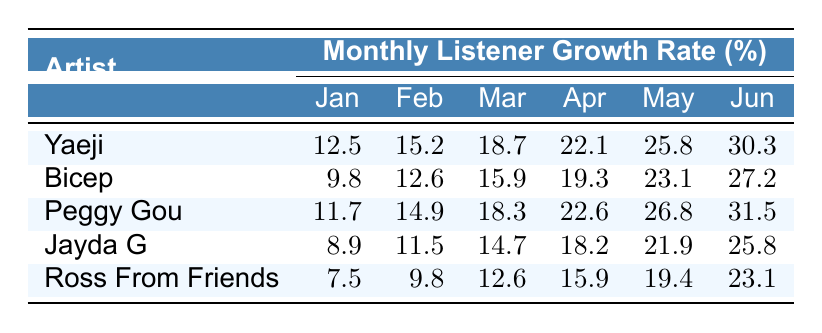What was Yaeji's listener growth rate in April in New York? The table shows that Yaeji's listener growth rate in New York for April is listed under the April column, which is 22.1%
Answer: 22.1% Which artist had the highest growth rate in London in June? By examining the June column for London, I can see that Peggy Gou's growth rate is 33.8%, which is higher than the others in that city
Answer: Peggy Gou What is the average listener growth rate for Ross From Friends across all months in Tokyo? To find the average, add up Ross From Friends' percentages in Tokyo: (6.1 + 8.2 + 10.7 + 13.6 + 16.8 + 20.3) = 75.7, then divide by 6, giving 75.7 / 6 = 12.62
Answer: 12.62 Was there any artist in Berlin whose growth rate was above 30% in May? Checking the May column for Berlin shows that the highest rate is 29.7% for Bicep, which means no artist reached 30%
Answer: No Which city had the highest monthly growth rate for Peggy Gou in March? For March, Peggy Gou's growth rate across the cities is compared: New York (18.3%), Los Angeles (17.1%), London (19.6%), Berlin (21.4%), and Tokyo (16.3%). The highest value is 21.4% in Berlin
Answer: Berlin How much higher is the growth rate of Yaeji in June compared to Jayda G in the same month? Yaeji's growth rate in June is 30.3%, while Jayda G's is 25.8%. The difference is calculated as 30.3 - 25.8 = 4.5
Answer: 4.5 Which artist consistently had the lowest listener growth rate across all months in Tokyo? By comparing each artist's percentages in Tokyo across all months, it’s evident that Ross From Friends had the lowest values consistently. The highest for him was 20.3%
Answer: Ross From Friends What is the total listener growth rate for Bicep in New York from January to June? Summing Bicep's percentages for New York: 9.8 + 12.6 + 15.9 + 19.3 + 23.1 + 27.2 = 107.9
Answer: 107.9 Did Yaeji show an increase in listener growth rate every month in Berlin? Reviewing Yaeji's growth rates for Berlin shows an increase month-to-month: 9.5, 12.7, 15.9, 19.2, 22.8, 26.5. Therefore, she did show consistent growth
Answer: Yes Which artist had a listener growth rate at or above 20% in New York for at least one month? Looking through New York's percentages for all artists, Yaeji, Peggy Gou, and Bicep all reached or exceeded 20% at some point.
Answer: Yes 